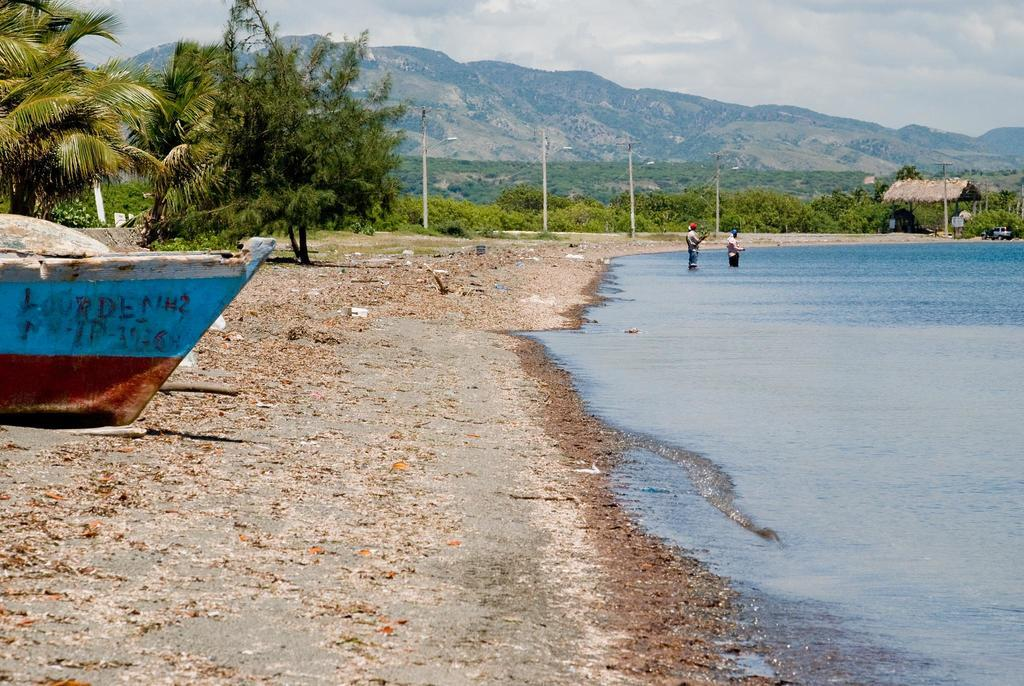How many people are in the water in the image? There are two persons in the water in the image. What type of structure can be seen in the image? There is a shelter in the image. What objects are present in the image that are used for support or stability? There are poles in the image. What type of natural vegetation is visible in the image? There are trees in the image. What type of natural landform is visible in the image? There are mountains in the image. What is the condition of the boat in the image? The boat is on the ground in the image. What part of the natural environment is visible in the background of the image? The sky is visible in the background of the image. What type of atmospheric phenomenon can be seen in the sky? Clouds are present in the sky. What type of cracker is being used as a flotation device in the image? There is no cracker present in the image, and therefore no such object is being used as a flotation device. What memories are the persons in the water discussing in the image? There is no indication in the image that the persons in the water are discussing any memories. 